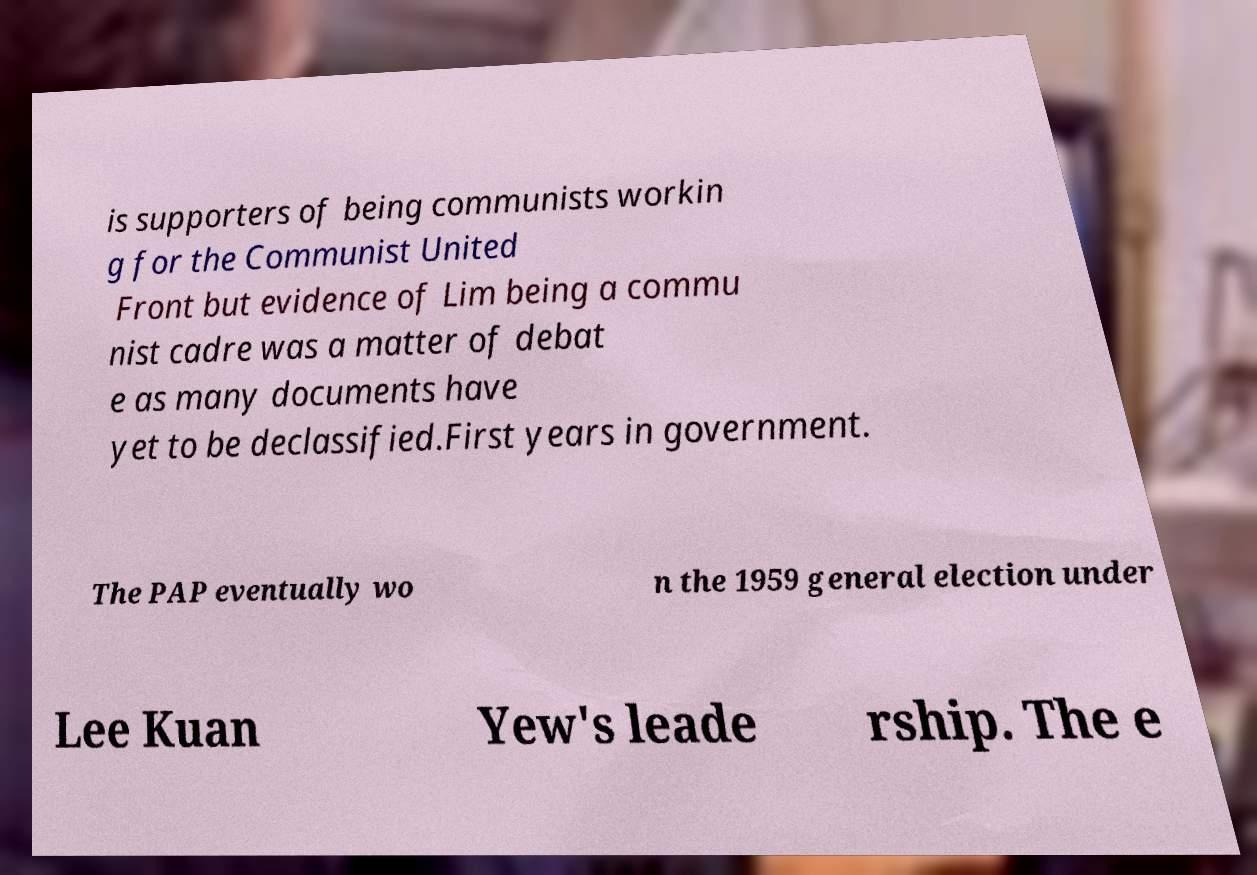For documentation purposes, I need the text within this image transcribed. Could you provide that? is supporters of being communists workin g for the Communist United Front but evidence of Lim being a commu nist cadre was a matter of debat e as many documents have yet to be declassified.First years in government. The PAP eventually wo n the 1959 general election under Lee Kuan Yew's leade rship. The e 